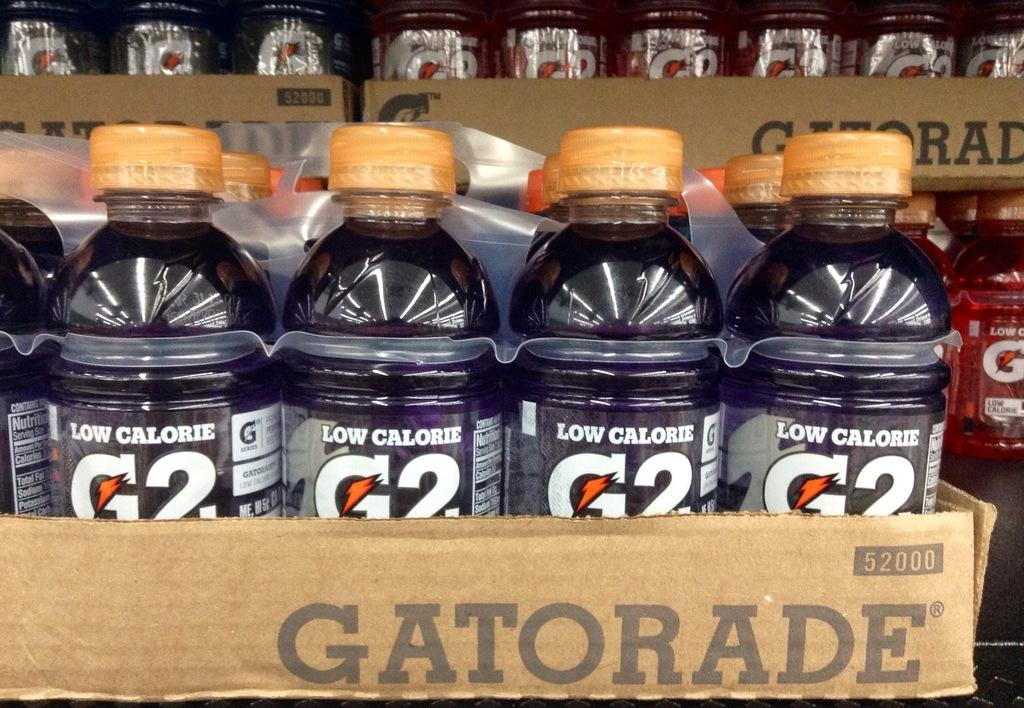<image>
Summarize the visual content of the image. a box of a pack of g2 low calorie gatorade bottles 